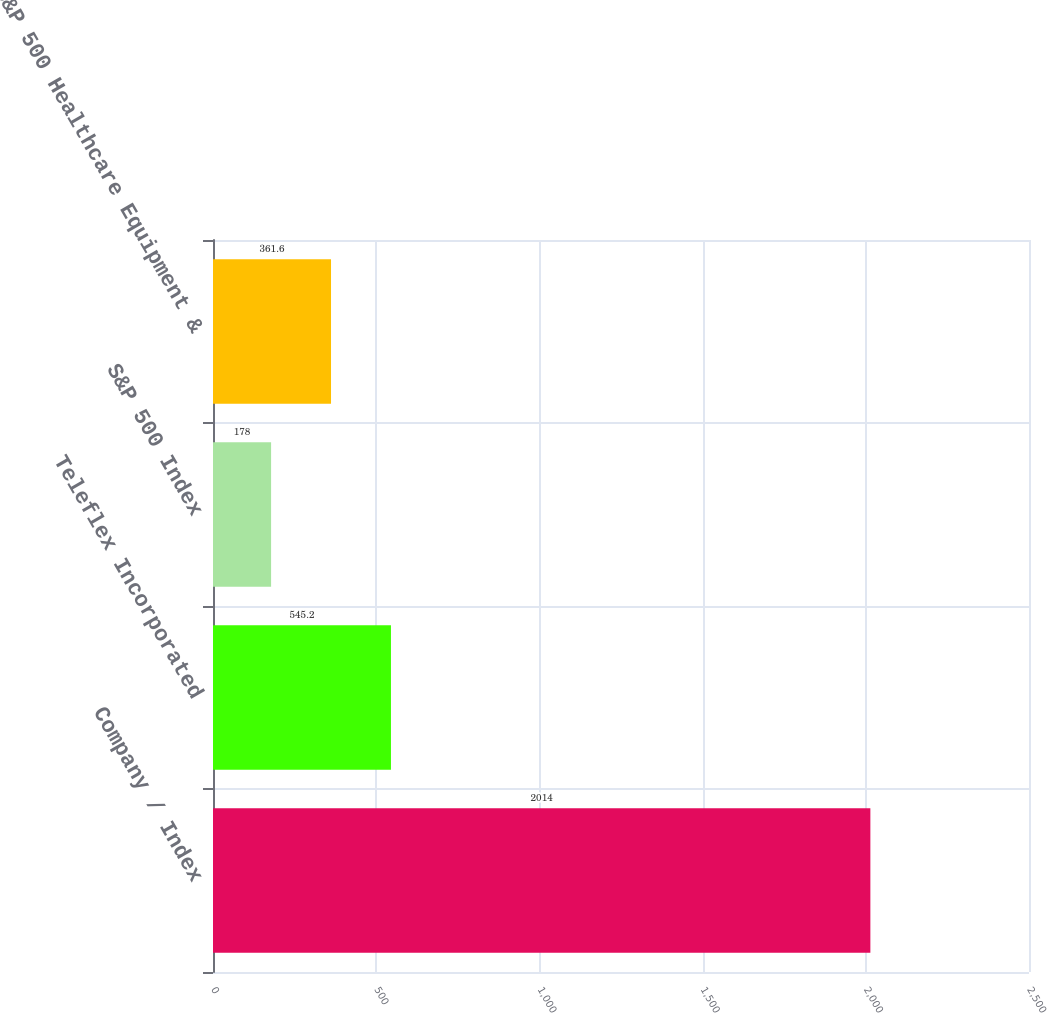Convert chart. <chart><loc_0><loc_0><loc_500><loc_500><bar_chart><fcel>Company / Index<fcel>Teleflex Incorporated<fcel>S&P 500 Index<fcel>S&P 500 Healthcare Equipment &<nl><fcel>2014<fcel>545.2<fcel>178<fcel>361.6<nl></chart> 